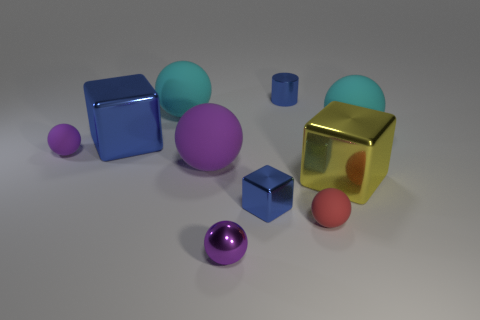Are there fewer tiny cylinders than small purple spheres?
Provide a succinct answer. Yes. Is there any other thing that has the same color as the cylinder?
Give a very brief answer. Yes. There is a cube that is to the left of the purple shiny sphere; what size is it?
Your response must be concise. Large. Are there more red matte things than large purple metallic cylinders?
Your answer should be compact. Yes. What is the material of the small red sphere?
Your response must be concise. Rubber. What number of other things are there of the same material as the big yellow object
Make the answer very short. 4. How many balls are there?
Make the answer very short. 6. What material is the other small purple thing that is the same shape as the tiny purple shiny thing?
Your answer should be compact. Rubber. Is the big blue cube to the left of the tiny block made of the same material as the large yellow cube?
Give a very brief answer. Yes. Is the number of purple rubber balls in front of the big purple matte sphere greater than the number of big cubes behind the big blue shiny thing?
Your answer should be very brief. No. 